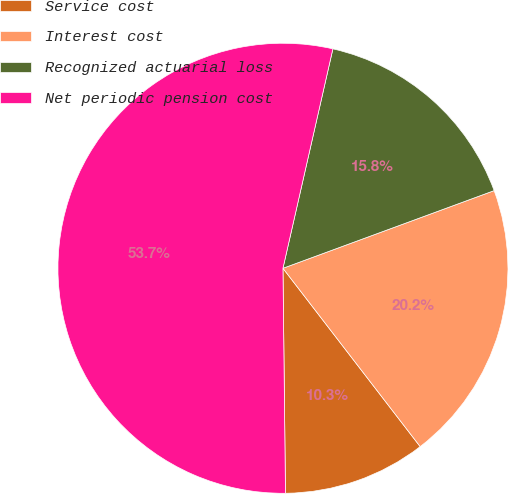Convert chart. <chart><loc_0><loc_0><loc_500><loc_500><pie_chart><fcel>Service cost<fcel>Interest cost<fcel>Recognized actuarial loss<fcel>Net periodic pension cost<nl><fcel>10.26%<fcel>20.17%<fcel>15.83%<fcel>53.74%<nl></chart> 